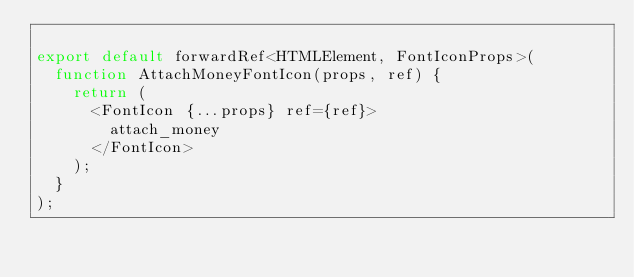Convert code to text. <code><loc_0><loc_0><loc_500><loc_500><_TypeScript_>
export default forwardRef<HTMLElement, FontIconProps>(
  function AttachMoneyFontIcon(props, ref) {
    return (
      <FontIcon {...props} ref={ref}>
        attach_money
      </FontIcon>
    );
  }
);
</code> 